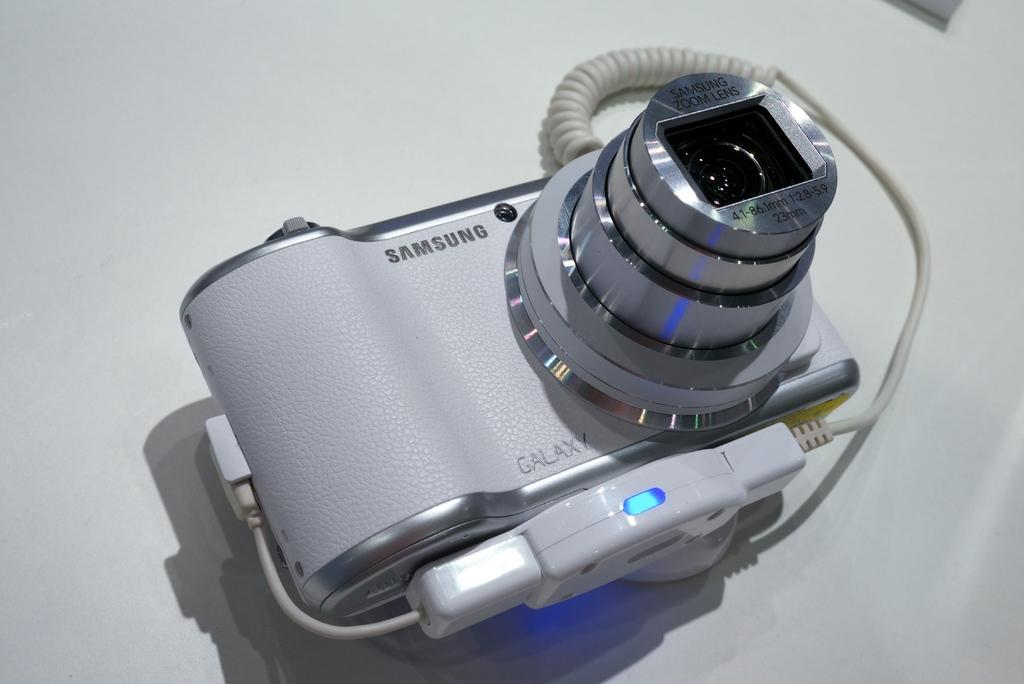What object is the main subject of the image? There is a camera in the image. Where is the camera located in the image? The camera is placed on a table. What type of cover is the fireman wearing in the image? There is no fireman or cover present in the image; it only features a camera placed on a table. 